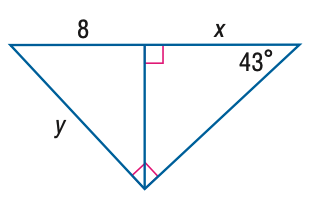Question: Find y. Round to the nearest tenth.
Choices:
A. 5.5
B. 8.6
C. 10.9
D. 11.7
Answer with the letter. Answer: D Question: Find x. Round to the nearest tenth.
Choices:
A. 4.6
B. 8.0
C. 9.2
D. 17.2
Answer with the letter. Answer: C 